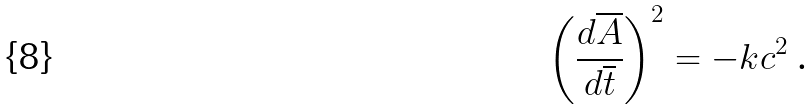<formula> <loc_0><loc_0><loc_500><loc_500>\left ( \frac { d \overline { A } } { d \overline { t } } \right ) ^ { 2 } = - k c ^ { 2 } \text { .}</formula> 